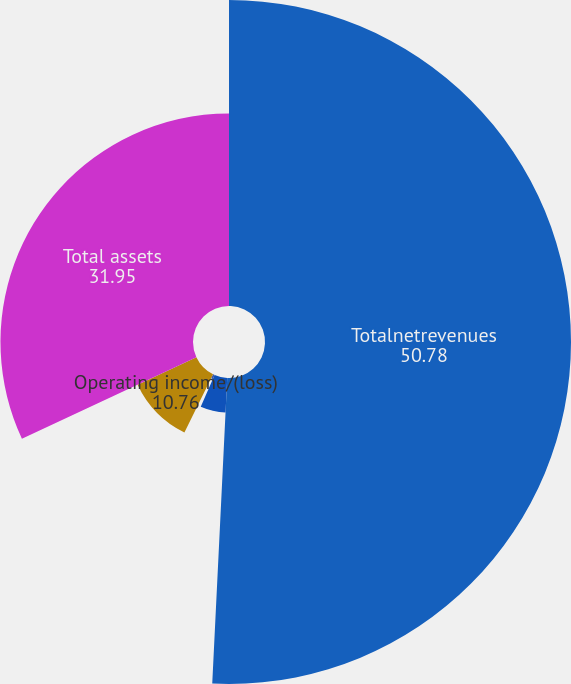<chart> <loc_0><loc_0><loc_500><loc_500><pie_chart><fcel>Totalnetrevenues<fcel>Depreciationandamortization<fcel>Incomefromequityinvestees<fcel>Operating income/(loss)<fcel>Total assets<nl><fcel>50.78%<fcel>5.76%<fcel>0.75%<fcel>10.76%<fcel>31.95%<nl></chart> 